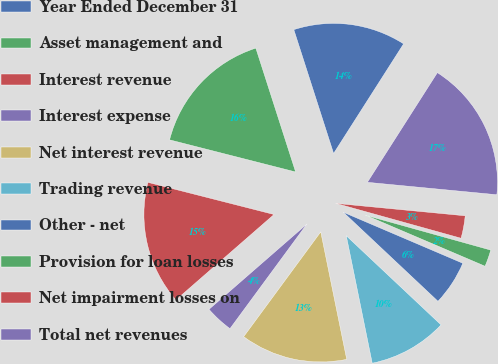<chart> <loc_0><loc_0><loc_500><loc_500><pie_chart><fcel>Year Ended December 31<fcel>Asset management and<fcel>Interest revenue<fcel>Interest expense<fcel>Net interest revenue<fcel>Trading revenue<fcel>Other - net<fcel>Provision for loan losses<fcel>Net impairment losses on<fcel>Total net revenues<nl><fcel>13.99%<fcel>16.08%<fcel>15.38%<fcel>3.5%<fcel>13.29%<fcel>9.79%<fcel>5.59%<fcel>2.1%<fcel>2.8%<fcel>17.48%<nl></chart> 